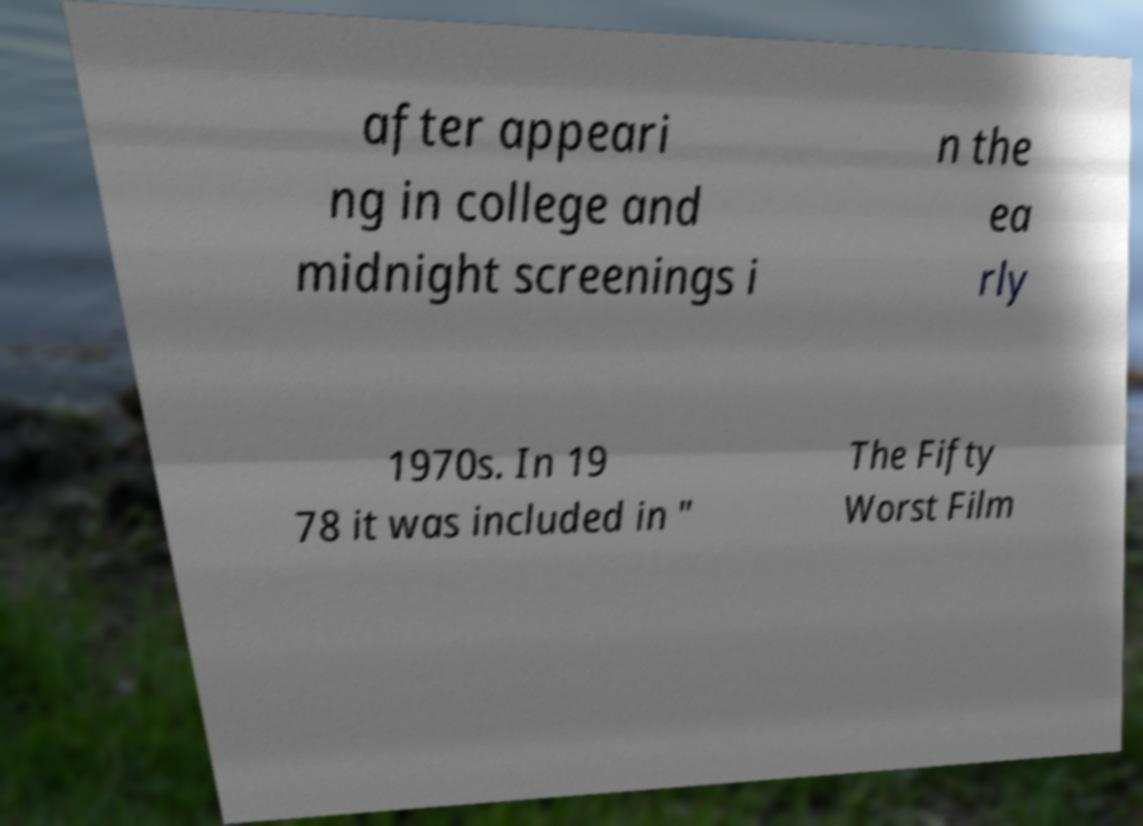Can you read and provide the text displayed in the image?This photo seems to have some interesting text. Can you extract and type it out for me? after appeari ng in college and midnight screenings i n the ea rly 1970s. In 19 78 it was included in " The Fifty Worst Film 